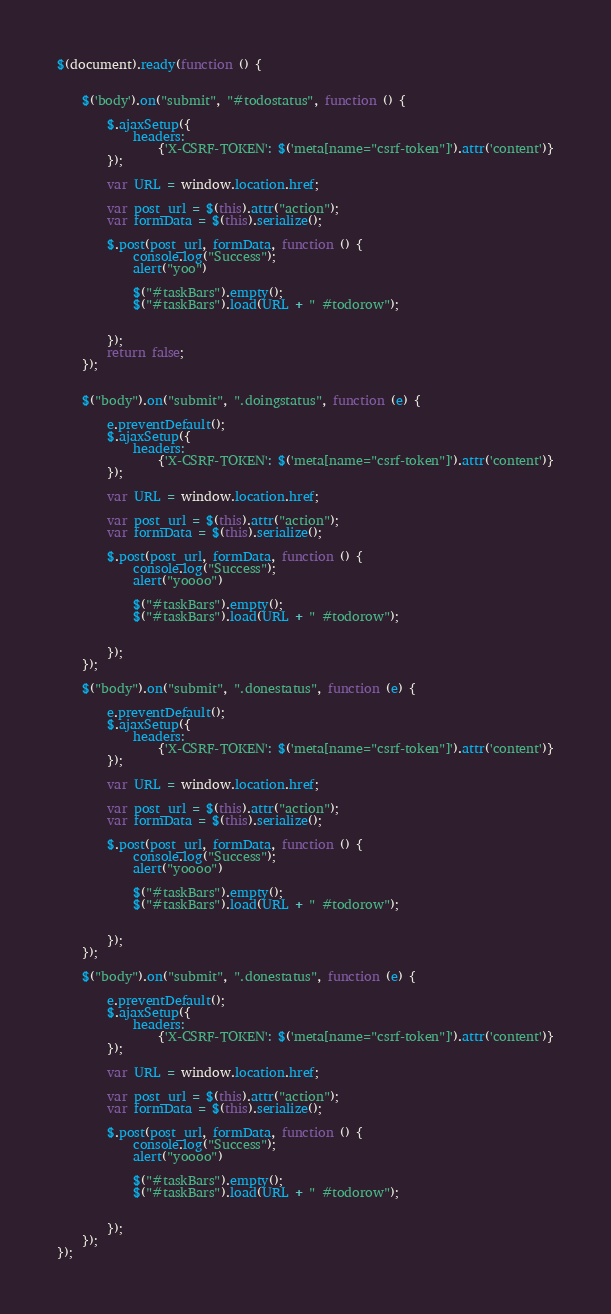<code> <loc_0><loc_0><loc_500><loc_500><_JavaScript_>$(document).ready(function () {


    $('body').on("submit", "#todostatus", function () {

        $.ajaxSetup({
            headers:
                {'X-CSRF-TOKEN': $('meta[name="csrf-token"]').attr('content')}
        });

        var URL = window.location.href;

        var post_url = $(this).attr("action");
        var formData = $(this).serialize();

        $.post(post_url, formData, function () {
            console.log("Success");
            alert("yoo")

            $("#taskBars").empty();
            $("#taskBars").load(URL + " #todorow");


        });
        return false;
    });


    $("body").on("submit", ".doingstatus", function (e) {

        e.preventDefault();
        $.ajaxSetup({
            headers:
                {'X-CSRF-TOKEN': $('meta[name="csrf-token"]').attr('content')}
        });

        var URL = window.location.href;

        var post_url = $(this).attr("action");
        var formData = $(this).serialize();

        $.post(post_url, formData, function () {
            console.log("Success");
            alert("yoooo")

            $("#taskBars").empty();
            $("#taskBars").load(URL + " #todorow");


        });
    });

    $("body").on("submit", ".donestatus", function (e) {

        e.preventDefault();
        $.ajaxSetup({
            headers:
                {'X-CSRF-TOKEN': $('meta[name="csrf-token"]').attr('content')}
        });

        var URL = window.location.href;

        var post_url = $(this).attr("action");
        var formData = $(this).serialize();

        $.post(post_url, formData, function () {
            console.log("Success");
            alert("yoooo")

            $("#taskBars").empty();
            $("#taskBars").load(URL + " #todorow");


        });
    });

    $("body").on("submit", ".donestatus", function (e) {

        e.preventDefault();
        $.ajaxSetup({
            headers:
                {'X-CSRF-TOKEN': $('meta[name="csrf-token"]').attr('content')}
        });

        var URL = window.location.href;

        var post_url = $(this).attr("action");
        var formData = $(this).serialize();

        $.post(post_url, formData, function () {
            console.log("Success");
            alert("yoooo")

            $("#taskBars").empty();
            $("#taskBars").load(URL + " #todorow");


        });
    });
});
</code> 